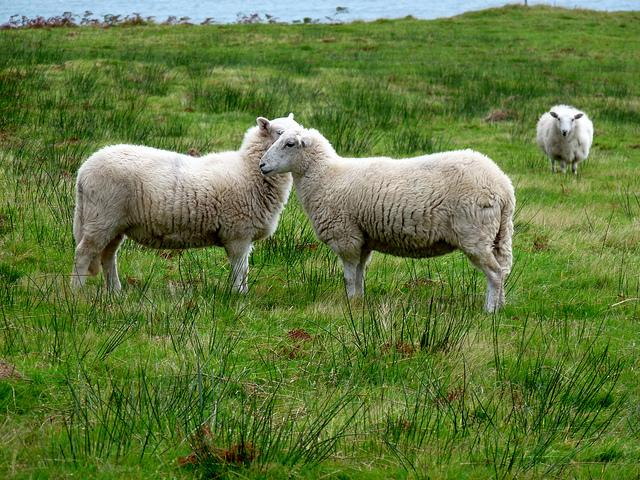How many sheep are standing around in the cape field? Please explain your reasoning. three. Two sheep are nuzzling and a third is behind them. 